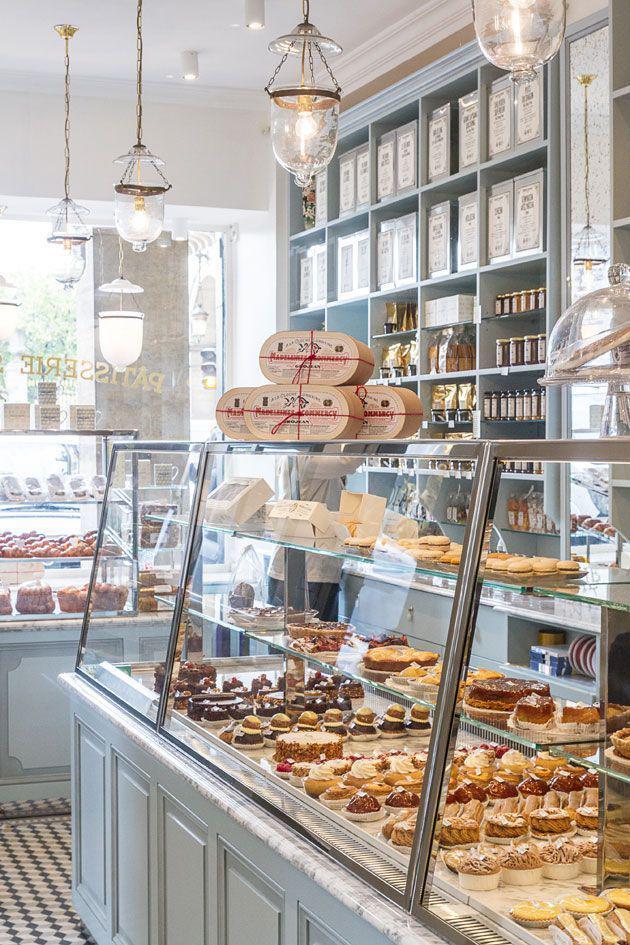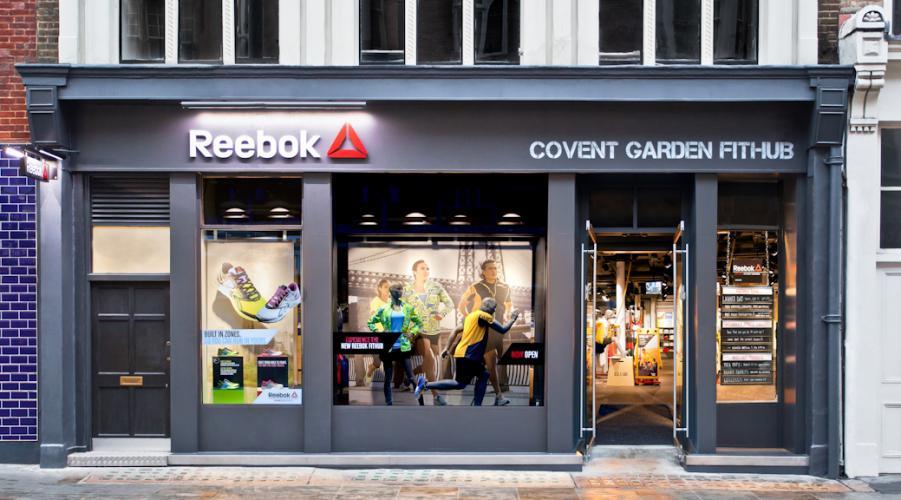The first image is the image on the left, the second image is the image on the right. For the images displayed, is the sentence "There is a striped awning in the image on the left." factually correct? Answer yes or no. No. 